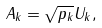Convert formula to latex. <formula><loc_0><loc_0><loc_500><loc_500>A _ { k } = \sqrt { p _ { k } } U _ { k } ,</formula> 